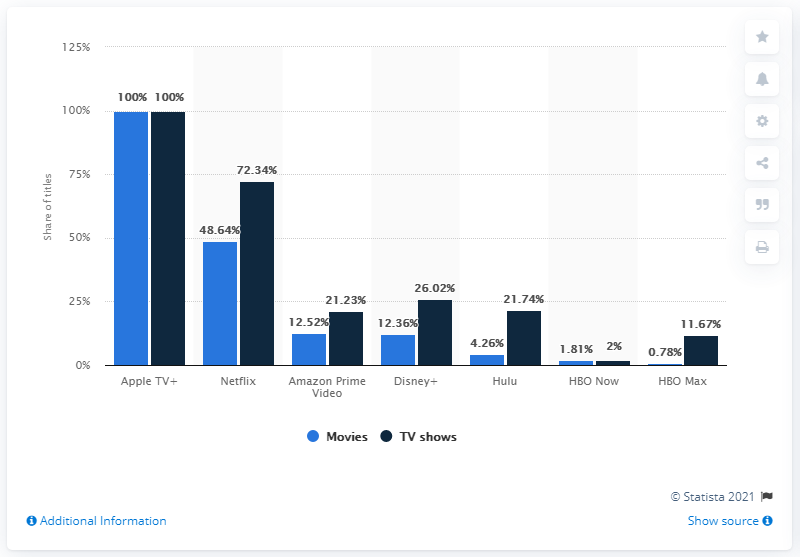Identify some key points in this picture. TV shows and movies available on Netflix differ in terms of their respective genres, release schedules, and viewing formats. The two bars representing 100% signify Apple TV+, a premium streaming service offered by Apple Inc. It has been revealed that Apple TV+ was the only other service that had a higher share of exclusive titles than Netflix. 